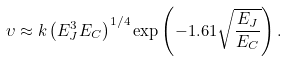Convert formula to latex. <formula><loc_0><loc_0><loc_500><loc_500>\upsilon \approx k \left ( E _ { J } ^ { 3 } E _ { C } \right ) ^ { 1 / 4 } \exp \left ( - 1 . 6 1 \sqrt { \frac { E _ { J } } { E _ { C } } } \right ) .</formula> 